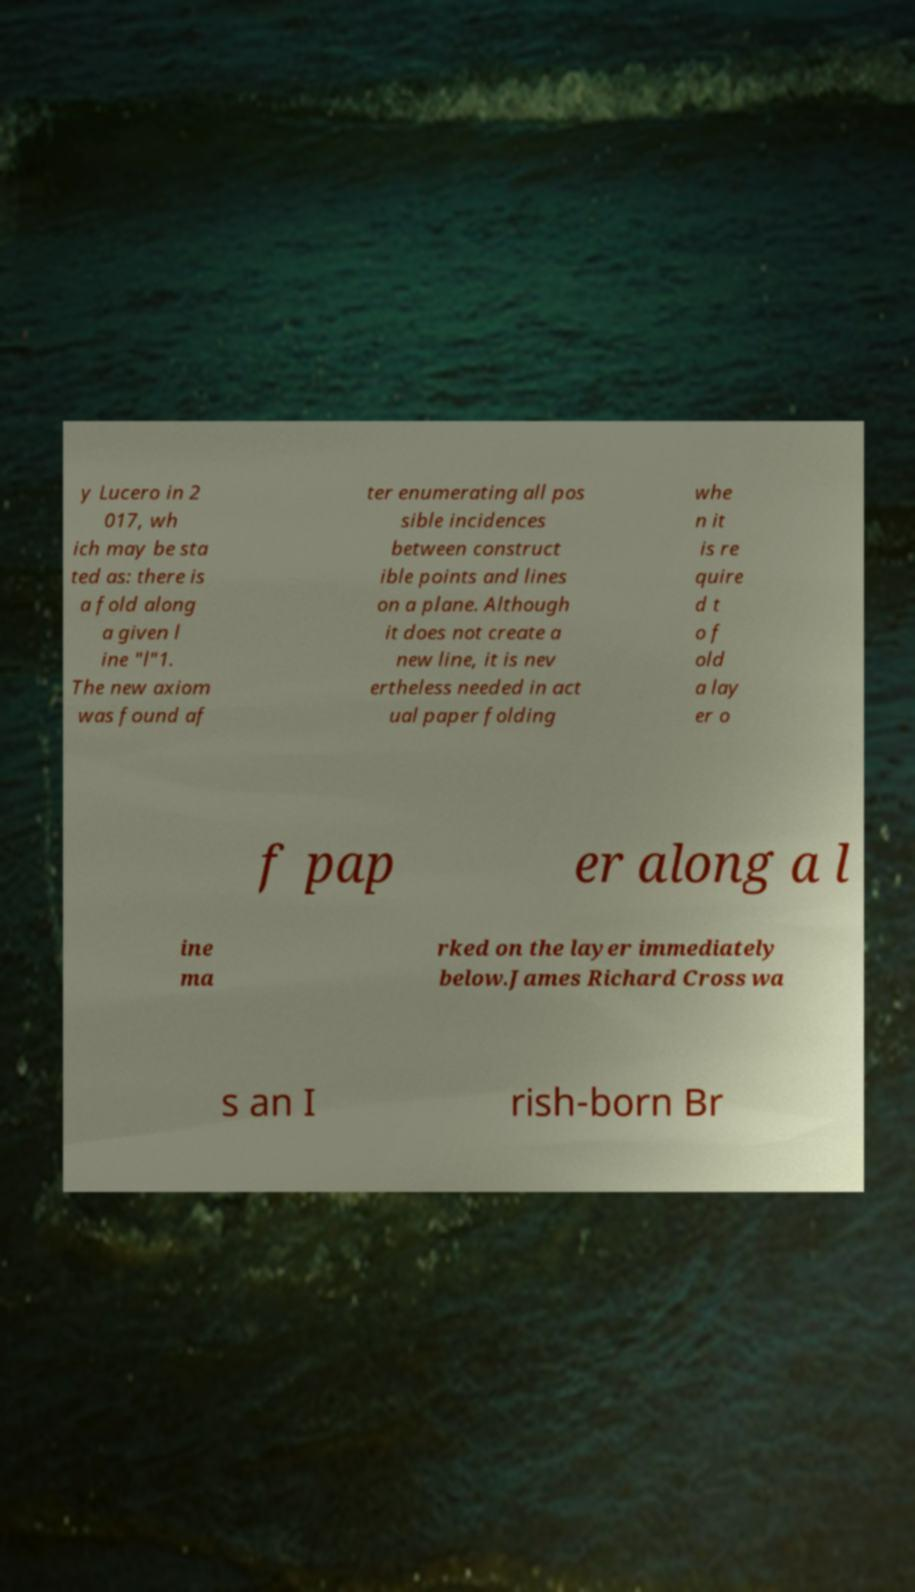Could you assist in decoding the text presented in this image and type it out clearly? y Lucero in 2 017, wh ich may be sta ted as: there is a fold along a given l ine "l"1. The new axiom was found af ter enumerating all pos sible incidences between construct ible points and lines on a plane. Although it does not create a new line, it is nev ertheless needed in act ual paper folding whe n it is re quire d t o f old a lay er o f pap er along a l ine ma rked on the layer immediately below.James Richard Cross wa s an I rish-born Br 